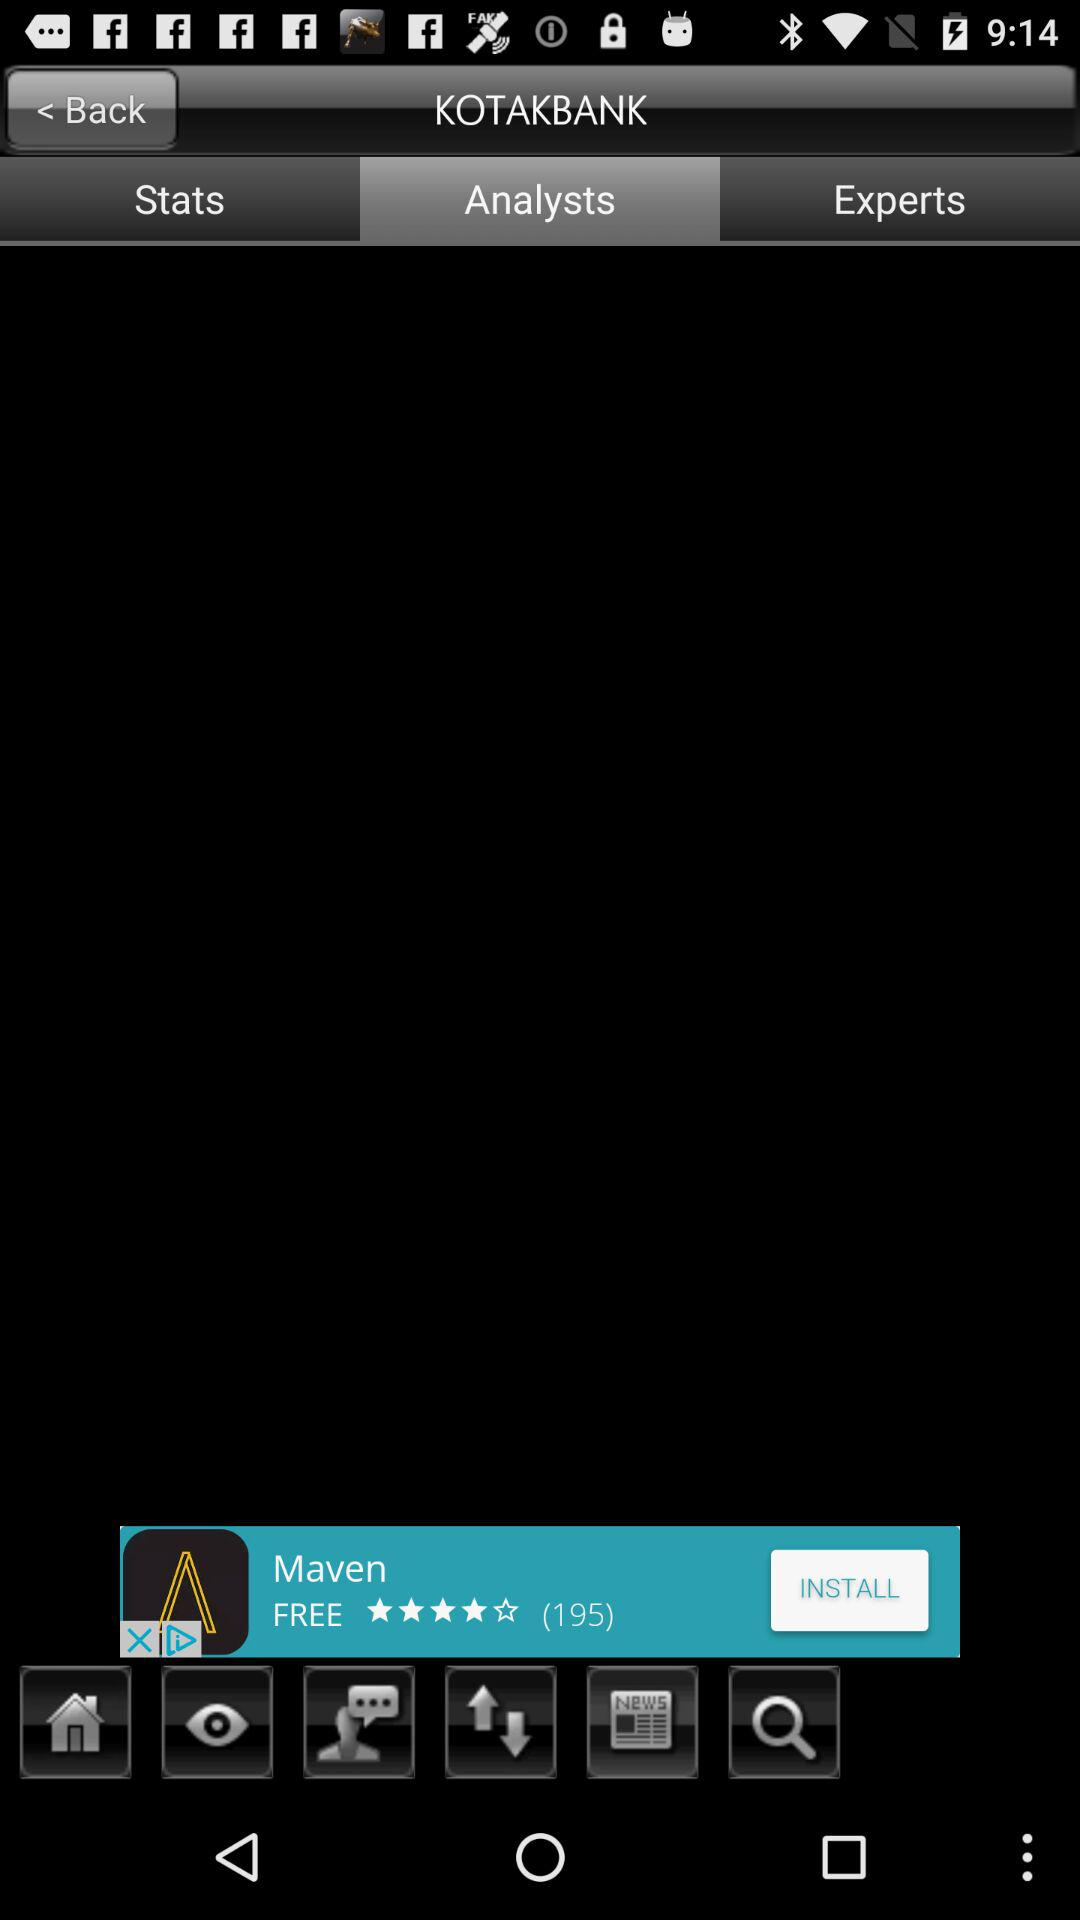Which tab is selected? The selected tab is "Analysts". 